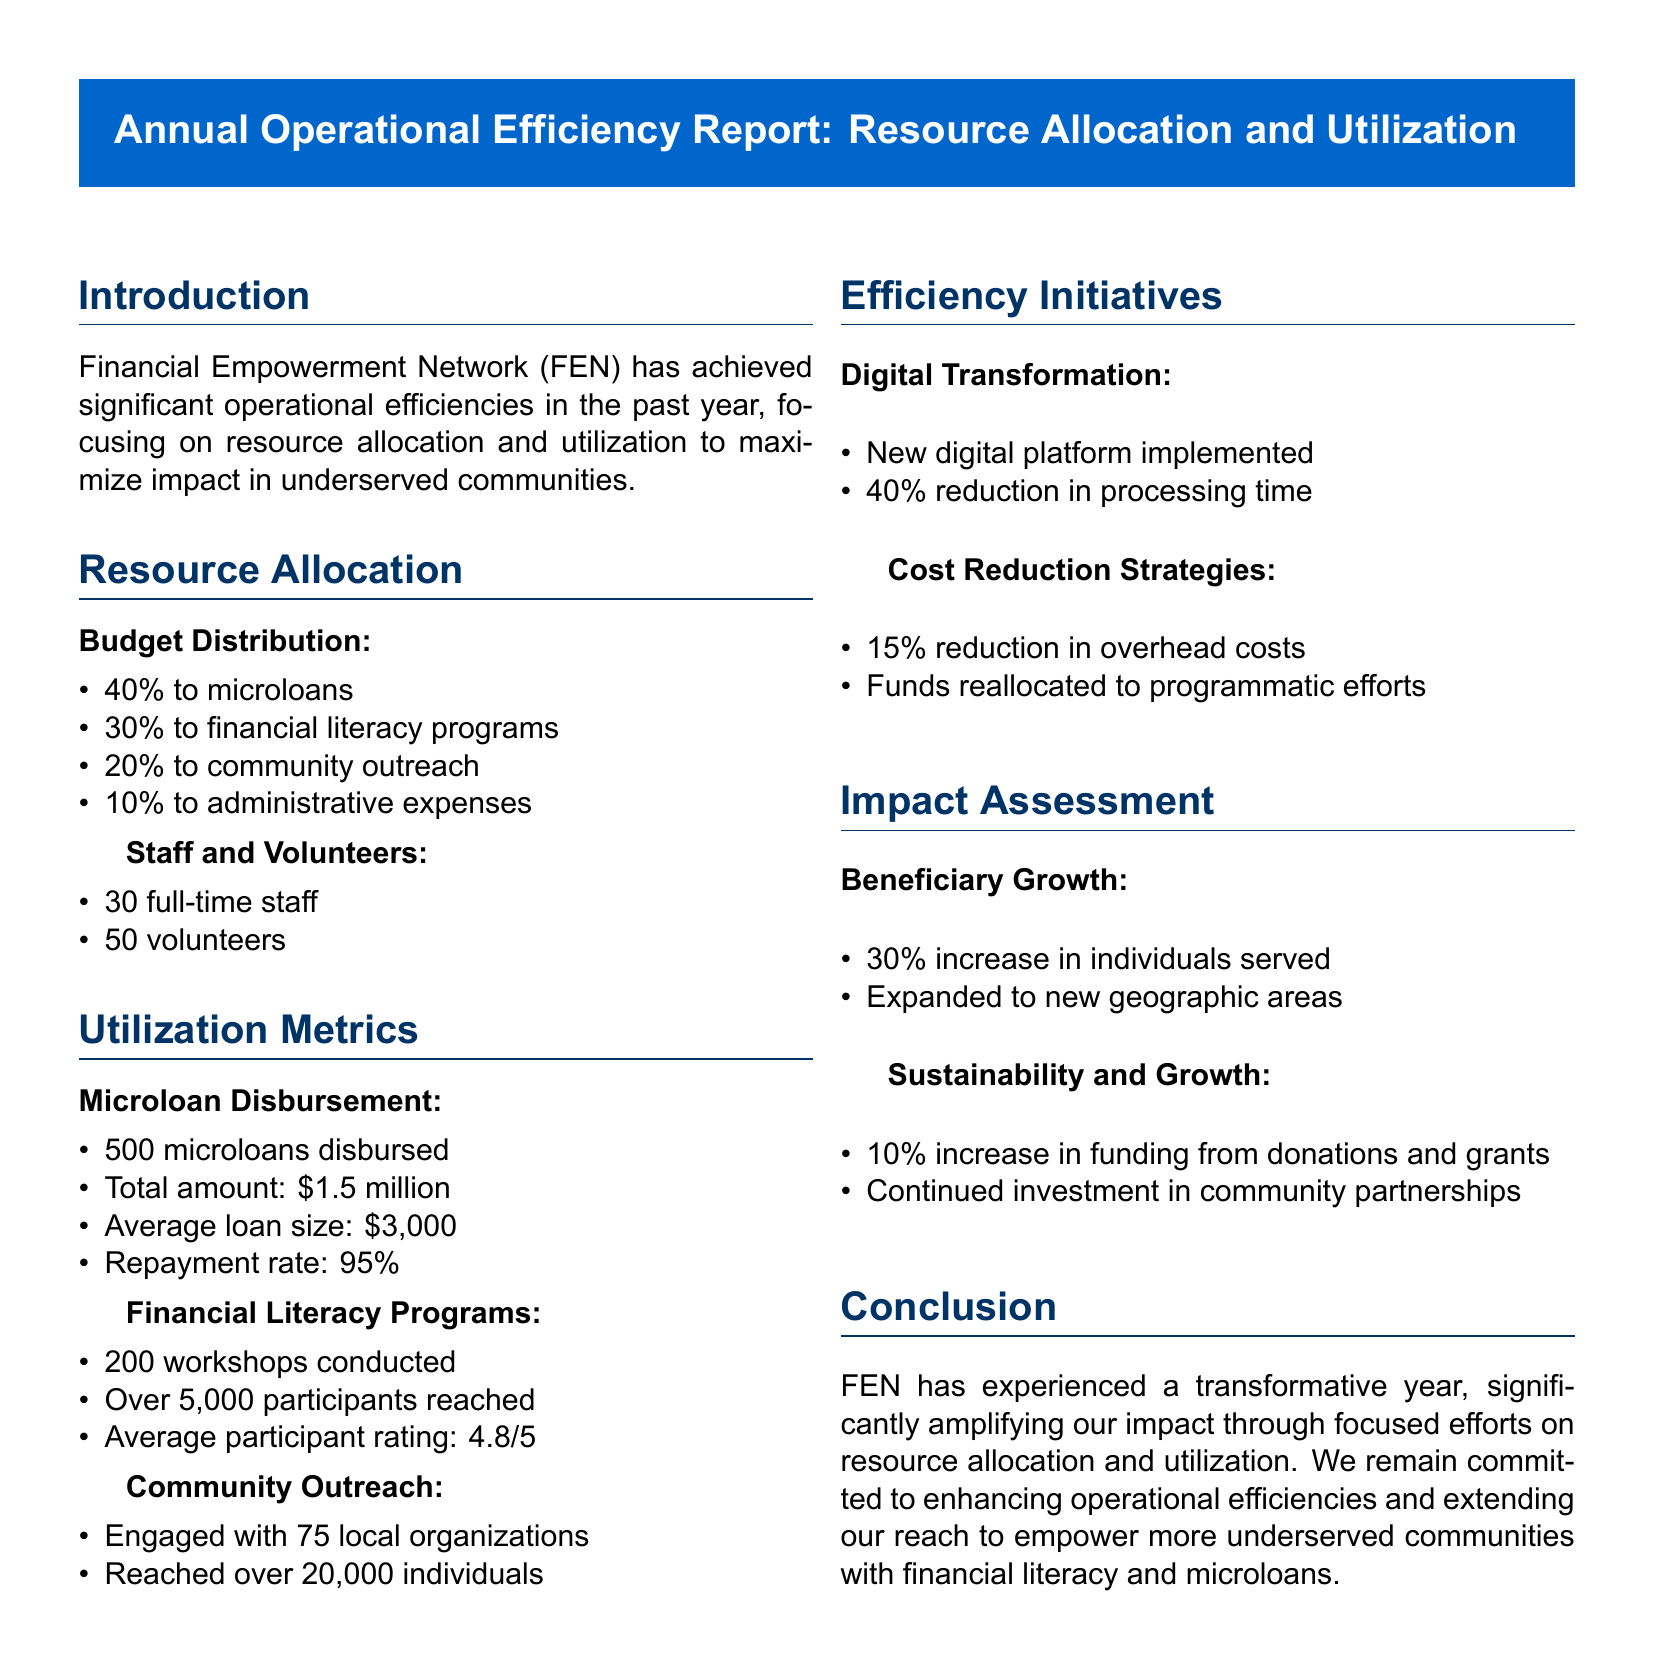What percentage of the budget is allocated to microloans? The budget distribution states that 40% is allocated to microloans.
Answer: 40% How many workshops were conducted in the financial literacy programs? The document notes that 200 workshops were conducted.
Answer: 200 What was the average loan size disbursed? The document specifies that the average loan size was $3,000.
Answer: $3,000 What was the repayment rate for microloans? The document states that the repayment rate is 95%.
Answer: 95% How many individuals were reached through community outreach? The document indicates that over 20,000 individuals were reached.
Answer: Over 20,000 What type of initiatives led to a reduction in processing time? The document mentions digital transformation initiatives that resulted in a 40% reduction in processing time.
Answer: Digital transformation What is the percentage increase in individuals served? The document reports a 30% increase in individuals served.
Answer: 30% What was the average participant rating for the financial literacy programs? The document mentions an average participant rating of 4.8/5.
Answer: 4.8/5 What is the increase in funding from donations and grants? The document states there was a 10% increase in funding from donations and grants.
Answer: 10% 